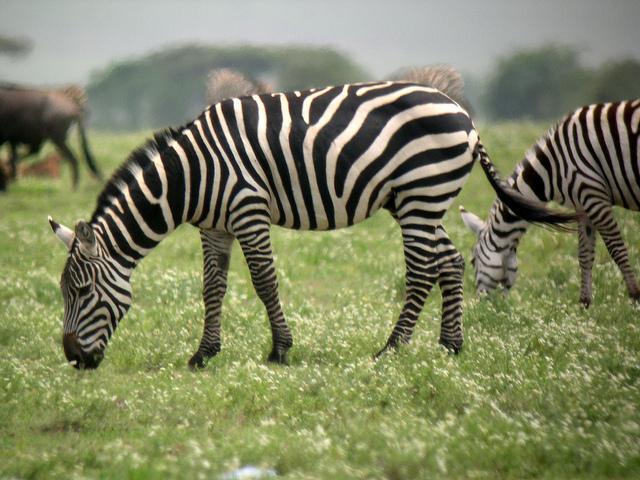How many zebras are there?
Give a very brief answer. 2. How many elephants constant?
Give a very brief answer. 0. 